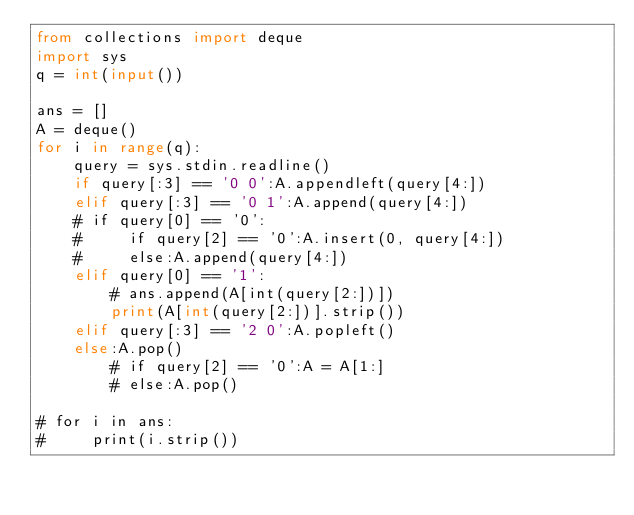<code> <loc_0><loc_0><loc_500><loc_500><_Python_>from collections import deque
import sys
q = int(input())

ans = []
A = deque()
for i in range(q):
    query = sys.stdin.readline()
    if query[:3] == '0 0':A.appendleft(query[4:])
    elif query[:3] == '0 1':A.append(query[4:])
    # if query[0] == '0':
    #     if query[2] == '0':A.insert(0, query[4:])
    #     else:A.append(query[4:])
    elif query[0] == '1':
        # ans.append(A[int(query[2:])])
        print(A[int(query[2:])].strip())
    elif query[:3] == '2 0':A.popleft()
    else:A.pop()
        # if query[2] == '0':A = A[1:]
        # else:A.pop()

# for i in ans:
#     print(i.strip())


</code> 